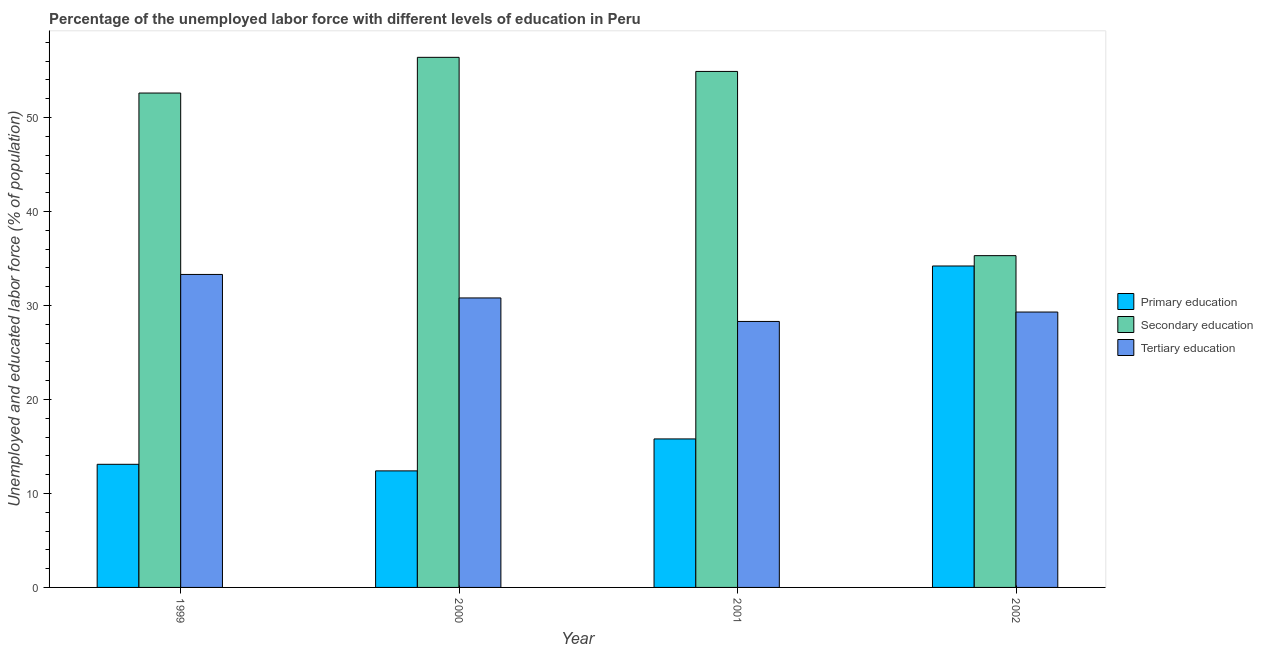How many groups of bars are there?
Offer a very short reply. 4. In how many cases, is the number of bars for a given year not equal to the number of legend labels?
Offer a very short reply. 0. What is the percentage of labor force who received tertiary education in 1999?
Offer a very short reply. 33.3. Across all years, what is the maximum percentage of labor force who received secondary education?
Make the answer very short. 56.4. Across all years, what is the minimum percentage of labor force who received secondary education?
Offer a terse response. 35.3. In which year was the percentage of labor force who received secondary education maximum?
Your answer should be compact. 2000. What is the total percentage of labor force who received secondary education in the graph?
Your answer should be very brief. 199.2. What is the difference between the percentage of labor force who received secondary education in 2000 and that in 2002?
Keep it short and to the point. 21.1. What is the difference between the percentage of labor force who received primary education in 2000 and the percentage of labor force who received secondary education in 2001?
Offer a very short reply. -3.4. What is the average percentage of labor force who received tertiary education per year?
Provide a short and direct response. 30.42. What is the ratio of the percentage of labor force who received primary education in 1999 to that in 2001?
Your response must be concise. 0.83. Is the percentage of labor force who received tertiary education in 2000 less than that in 2001?
Provide a short and direct response. No. What is the difference between the highest and the second highest percentage of labor force who received primary education?
Offer a very short reply. 18.4. What is the difference between the highest and the lowest percentage of labor force who received secondary education?
Your response must be concise. 21.1. What does the 2nd bar from the right in 2001 represents?
Offer a terse response. Secondary education. Is it the case that in every year, the sum of the percentage of labor force who received primary education and percentage of labor force who received secondary education is greater than the percentage of labor force who received tertiary education?
Your answer should be very brief. Yes. How many bars are there?
Ensure brevity in your answer.  12. How many years are there in the graph?
Offer a terse response. 4. What is the difference between two consecutive major ticks on the Y-axis?
Make the answer very short. 10. Are the values on the major ticks of Y-axis written in scientific E-notation?
Your answer should be very brief. No. Does the graph contain grids?
Give a very brief answer. No. How are the legend labels stacked?
Your answer should be very brief. Vertical. What is the title of the graph?
Offer a very short reply. Percentage of the unemployed labor force with different levels of education in Peru. What is the label or title of the Y-axis?
Provide a short and direct response. Unemployed and educated labor force (% of population). What is the Unemployed and educated labor force (% of population) of Primary education in 1999?
Your answer should be very brief. 13.1. What is the Unemployed and educated labor force (% of population) in Secondary education in 1999?
Offer a terse response. 52.6. What is the Unemployed and educated labor force (% of population) of Tertiary education in 1999?
Ensure brevity in your answer.  33.3. What is the Unemployed and educated labor force (% of population) in Primary education in 2000?
Provide a short and direct response. 12.4. What is the Unemployed and educated labor force (% of population) of Secondary education in 2000?
Your answer should be compact. 56.4. What is the Unemployed and educated labor force (% of population) of Tertiary education in 2000?
Provide a succinct answer. 30.8. What is the Unemployed and educated labor force (% of population) of Primary education in 2001?
Keep it short and to the point. 15.8. What is the Unemployed and educated labor force (% of population) of Secondary education in 2001?
Provide a succinct answer. 54.9. What is the Unemployed and educated labor force (% of population) in Tertiary education in 2001?
Make the answer very short. 28.3. What is the Unemployed and educated labor force (% of population) in Primary education in 2002?
Your answer should be very brief. 34.2. What is the Unemployed and educated labor force (% of population) of Secondary education in 2002?
Offer a terse response. 35.3. What is the Unemployed and educated labor force (% of population) of Tertiary education in 2002?
Keep it short and to the point. 29.3. Across all years, what is the maximum Unemployed and educated labor force (% of population) of Primary education?
Keep it short and to the point. 34.2. Across all years, what is the maximum Unemployed and educated labor force (% of population) in Secondary education?
Provide a succinct answer. 56.4. Across all years, what is the maximum Unemployed and educated labor force (% of population) in Tertiary education?
Keep it short and to the point. 33.3. Across all years, what is the minimum Unemployed and educated labor force (% of population) in Primary education?
Keep it short and to the point. 12.4. Across all years, what is the minimum Unemployed and educated labor force (% of population) of Secondary education?
Offer a very short reply. 35.3. Across all years, what is the minimum Unemployed and educated labor force (% of population) of Tertiary education?
Offer a terse response. 28.3. What is the total Unemployed and educated labor force (% of population) of Primary education in the graph?
Offer a very short reply. 75.5. What is the total Unemployed and educated labor force (% of population) of Secondary education in the graph?
Keep it short and to the point. 199.2. What is the total Unemployed and educated labor force (% of population) of Tertiary education in the graph?
Keep it short and to the point. 121.7. What is the difference between the Unemployed and educated labor force (% of population) in Primary education in 1999 and that in 2000?
Your answer should be compact. 0.7. What is the difference between the Unemployed and educated labor force (% of population) of Secondary education in 1999 and that in 2000?
Ensure brevity in your answer.  -3.8. What is the difference between the Unemployed and educated labor force (% of population) in Primary education in 1999 and that in 2001?
Give a very brief answer. -2.7. What is the difference between the Unemployed and educated labor force (% of population) in Secondary education in 1999 and that in 2001?
Offer a terse response. -2.3. What is the difference between the Unemployed and educated labor force (% of population) in Tertiary education in 1999 and that in 2001?
Keep it short and to the point. 5. What is the difference between the Unemployed and educated labor force (% of population) of Primary education in 1999 and that in 2002?
Make the answer very short. -21.1. What is the difference between the Unemployed and educated labor force (% of population) of Tertiary education in 1999 and that in 2002?
Your answer should be very brief. 4. What is the difference between the Unemployed and educated labor force (% of population) in Primary education in 2000 and that in 2002?
Your response must be concise. -21.8. What is the difference between the Unemployed and educated labor force (% of population) of Secondary education in 2000 and that in 2002?
Offer a terse response. 21.1. What is the difference between the Unemployed and educated labor force (% of population) in Tertiary education in 2000 and that in 2002?
Your answer should be compact. 1.5. What is the difference between the Unemployed and educated labor force (% of population) in Primary education in 2001 and that in 2002?
Keep it short and to the point. -18.4. What is the difference between the Unemployed and educated labor force (% of population) of Secondary education in 2001 and that in 2002?
Make the answer very short. 19.6. What is the difference between the Unemployed and educated labor force (% of population) in Primary education in 1999 and the Unemployed and educated labor force (% of population) in Secondary education in 2000?
Your answer should be compact. -43.3. What is the difference between the Unemployed and educated labor force (% of population) of Primary education in 1999 and the Unemployed and educated labor force (% of population) of Tertiary education in 2000?
Make the answer very short. -17.7. What is the difference between the Unemployed and educated labor force (% of population) in Secondary education in 1999 and the Unemployed and educated labor force (% of population) in Tertiary education in 2000?
Provide a succinct answer. 21.8. What is the difference between the Unemployed and educated labor force (% of population) in Primary education in 1999 and the Unemployed and educated labor force (% of population) in Secondary education in 2001?
Offer a very short reply. -41.8. What is the difference between the Unemployed and educated labor force (% of population) of Primary education in 1999 and the Unemployed and educated labor force (% of population) of Tertiary education in 2001?
Offer a very short reply. -15.2. What is the difference between the Unemployed and educated labor force (% of population) in Secondary education in 1999 and the Unemployed and educated labor force (% of population) in Tertiary education in 2001?
Keep it short and to the point. 24.3. What is the difference between the Unemployed and educated labor force (% of population) in Primary education in 1999 and the Unemployed and educated labor force (% of population) in Secondary education in 2002?
Your answer should be compact. -22.2. What is the difference between the Unemployed and educated labor force (% of population) of Primary education in 1999 and the Unemployed and educated labor force (% of population) of Tertiary education in 2002?
Your response must be concise. -16.2. What is the difference between the Unemployed and educated labor force (% of population) of Secondary education in 1999 and the Unemployed and educated labor force (% of population) of Tertiary education in 2002?
Your answer should be very brief. 23.3. What is the difference between the Unemployed and educated labor force (% of population) in Primary education in 2000 and the Unemployed and educated labor force (% of population) in Secondary education in 2001?
Offer a very short reply. -42.5. What is the difference between the Unemployed and educated labor force (% of population) in Primary education in 2000 and the Unemployed and educated labor force (% of population) in Tertiary education in 2001?
Your answer should be compact. -15.9. What is the difference between the Unemployed and educated labor force (% of population) in Secondary education in 2000 and the Unemployed and educated labor force (% of population) in Tertiary education in 2001?
Provide a succinct answer. 28.1. What is the difference between the Unemployed and educated labor force (% of population) of Primary education in 2000 and the Unemployed and educated labor force (% of population) of Secondary education in 2002?
Provide a succinct answer. -22.9. What is the difference between the Unemployed and educated labor force (% of population) in Primary education in 2000 and the Unemployed and educated labor force (% of population) in Tertiary education in 2002?
Your answer should be compact. -16.9. What is the difference between the Unemployed and educated labor force (% of population) in Secondary education in 2000 and the Unemployed and educated labor force (% of population) in Tertiary education in 2002?
Provide a succinct answer. 27.1. What is the difference between the Unemployed and educated labor force (% of population) of Primary education in 2001 and the Unemployed and educated labor force (% of population) of Secondary education in 2002?
Make the answer very short. -19.5. What is the difference between the Unemployed and educated labor force (% of population) of Secondary education in 2001 and the Unemployed and educated labor force (% of population) of Tertiary education in 2002?
Ensure brevity in your answer.  25.6. What is the average Unemployed and educated labor force (% of population) in Primary education per year?
Offer a very short reply. 18.88. What is the average Unemployed and educated labor force (% of population) in Secondary education per year?
Keep it short and to the point. 49.8. What is the average Unemployed and educated labor force (% of population) of Tertiary education per year?
Ensure brevity in your answer.  30.43. In the year 1999, what is the difference between the Unemployed and educated labor force (% of population) of Primary education and Unemployed and educated labor force (% of population) of Secondary education?
Keep it short and to the point. -39.5. In the year 1999, what is the difference between the Unemployed and educated labor force (% of population) of Primary education and Unemployed and educated labor force (% of population) of Tertiary education?
Give a very brief answer. -20.2. In the year 1999, what is the difference between the Unemployed and educated labor force (% of population) in Secondary education and Unemployed and educated labor force (% of population) in Tertiary education?
Give a very brief answer. 19.3. In the year 2000, what is the difference between the Unemployed and educated labor force (% of population) of Primary education and Unemployed and educated labor force (% of population) of Secondary education?
Provide a short and direct response. -44. In the year 2000, what is the difference between the Unemployed and educated labor force (% of population) of Primary education and Unemployed and educated labor force (% of population) of Tertiary education?
Give a very brief answer. -18.4. In the year 2000, what is the difference between the Unemployed and educated labor force (% of population) of Secondary education and Unemployed and educated labor force (% of population) of Tertiary education?
Your answer should be very brief. 25.6. In the year 2001, what is the difference between the Unemployed and educated labor force (% of population) of Primary education and Unemployed and educated labor force (% of population) of Secondary education?
Your response must be concise. -39.1. In the year 2001, what is the difference between the Unemployed and educated labor force (% of population) of Primary education and Unemployed and educated labor force (% of population) of Tertiary education?
Keep it short and to the point. -12.5. In the year 2001, what is the difference between the Unemployed and educated labor force (% of population) of Secondary education and Unemployed and educated labor force (% of population) of Tertiary education?
Provide a succinct answer. 26.6. What is the ratio of the Unemployed and educated labor force (% of population) in Primary education in 1999 to that in 2000?
Ensure brevity in your answer.  1.06. What is the ratio of the Unemployed and educated labor force (% of population) in Secondary education in 1999 to that in 2000?
Ensure brevity in your answer.  0.93. What is the ratio of the Unemployed and educated labor force (% of population) in Tertiary education in 1999 to that in 2000?
Offer a very short reply. 1.08. What is the ratio of the Unemployed and educated labor force (% of population) in Primary education in 1999 to that in 2001?
Your response must be concise. 0.83. What is the ratio of the Unemployed and educated labor force (% of population) in Secondary education in 1999 to that in 2001?
Keep it short and to the point. 0.96. What is the ratio of the Unemployed and educated labor force (% of population) of Tertiary education in 1999 to that in 2001?
Keep it short and to the point. 1.18. What is the ratio of the Unemployed and educated labor force (% of population) in Primary education in 1999 to that in 2002?
Offer a very short reply. 0.38. What is the ratio of the Unemployed and educated labor force (% of population) of Secondary education in 1999 to that in 2002?
Provide a short and direct response. 1.49. What is the ratio of the Unemployed and educated labor force (% of population) in Tertiary education in 1999 to that in 2002?
Make the answer very short. 1.14. What is the ratio of the Unemployed and educated labor force (% of population) in Primary education in 2000 to that in 2001?
Make the answer very short. 0.78. What is the ratio of the Unemployed and educated labor force (% of population) in Secondary education in 2000 to that in 2001?
Give a very brief answer. 1.03. What is the ratio of the Unemployed and educated labor force (% of population) in Tertiary education in 2000 to that in 2001?
Make the answer very short. 1.09. What is the ratio of the Unemployed and educated labor force (% of population) in Primary education in 2000 to that in 2002?
Offer a terse response. 0.36. What is the ratio of the Unemployed and educated labor force (% of population) in Secondary education in 2000 to that in 2002?
Offer a terse response. 1.6. What is the ratio of the Unemployed and educated labor force (% of population) of Tertiary education in 2000 to that in 2002?
Keep it short and to the point. 1.05. What is the ratio of the Unemployed and educated labor force (% of population) of Primary education in 2001 to that in 2002?
Provide a succinct answer. 0.46. What is the ratio of the Unemployed and educated labor force (% of population) of Secondary education in 2001 to that in 2002?
Make the answer very short. 1.56. What is the ratio of the Unemployed and educated labor force (% of population) of Tertiary education in 2001 to that in 2002?
Offer a very short reply. 0.97. What is the difference between the highest and the second highest Unemployed and educated labor force (% of population) in Primary education?
Offer a very short reply. 18.4. What is the difference between the highest and the second highest Unemployed and educated labor force (% of population) in Secondary education?
Your answer should be compact. 1.5. What is the difference between the highest and the lowest Unemployed and educated labor force (% of population) in Primary education?
Provide a short and direct response. 21.8. What is the difference between the highest and the lowest Unemployed and educated labor force (% of population) in Secondary education?
Your response must be concise. 21.1. 